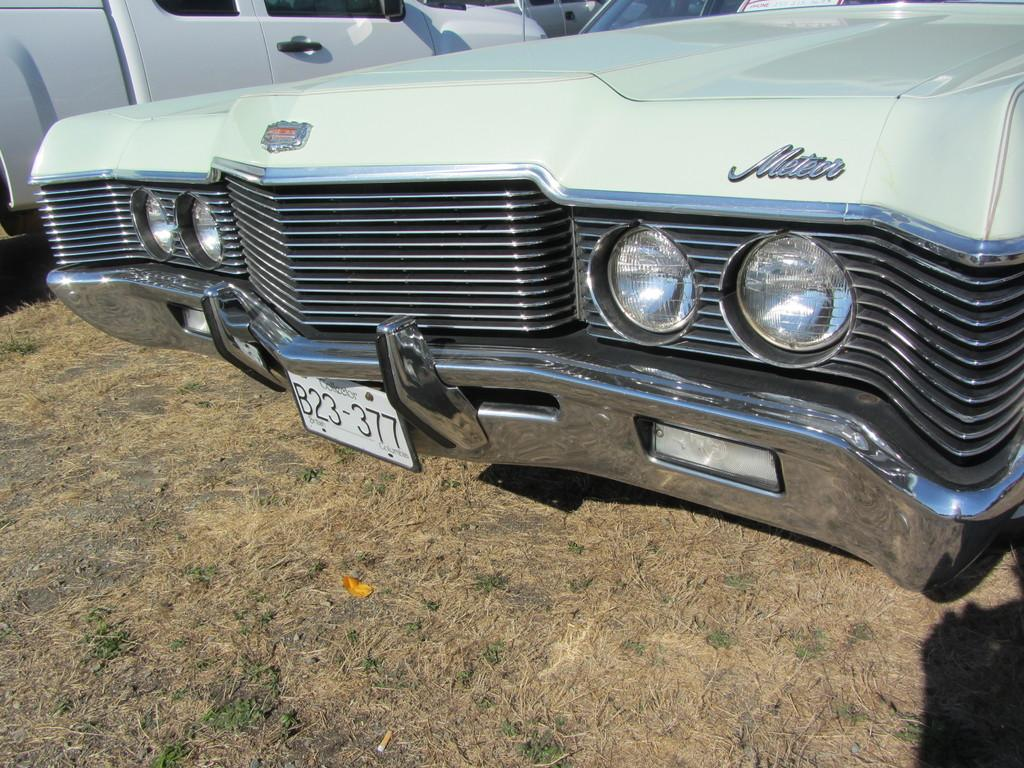What types of objects are present in the image? There are vehicles in the image. Where are the vehicles located? The vehicles are parked on the grass. What type of dinner is being served on the grass in the image? There is no dinner or any food present in the image; it only features vehicles parked on the grass. 